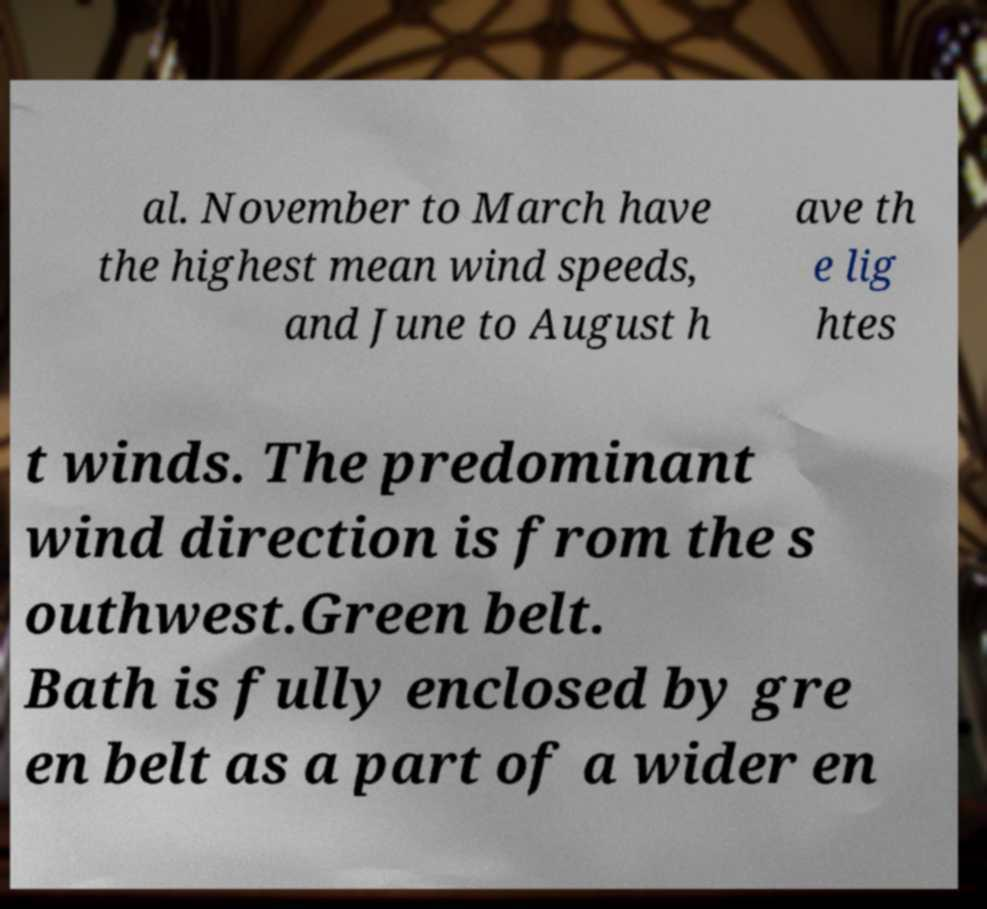I need the written content from this picture converted into text. Can you do that? al. November to March have the highest mean wind speeds, and June to August h ave th e lig htes t winds. The predominant wind direction is from the s outhwest.Green belt. Bath is fully enclosed by gre en belt as a part of a wider en 